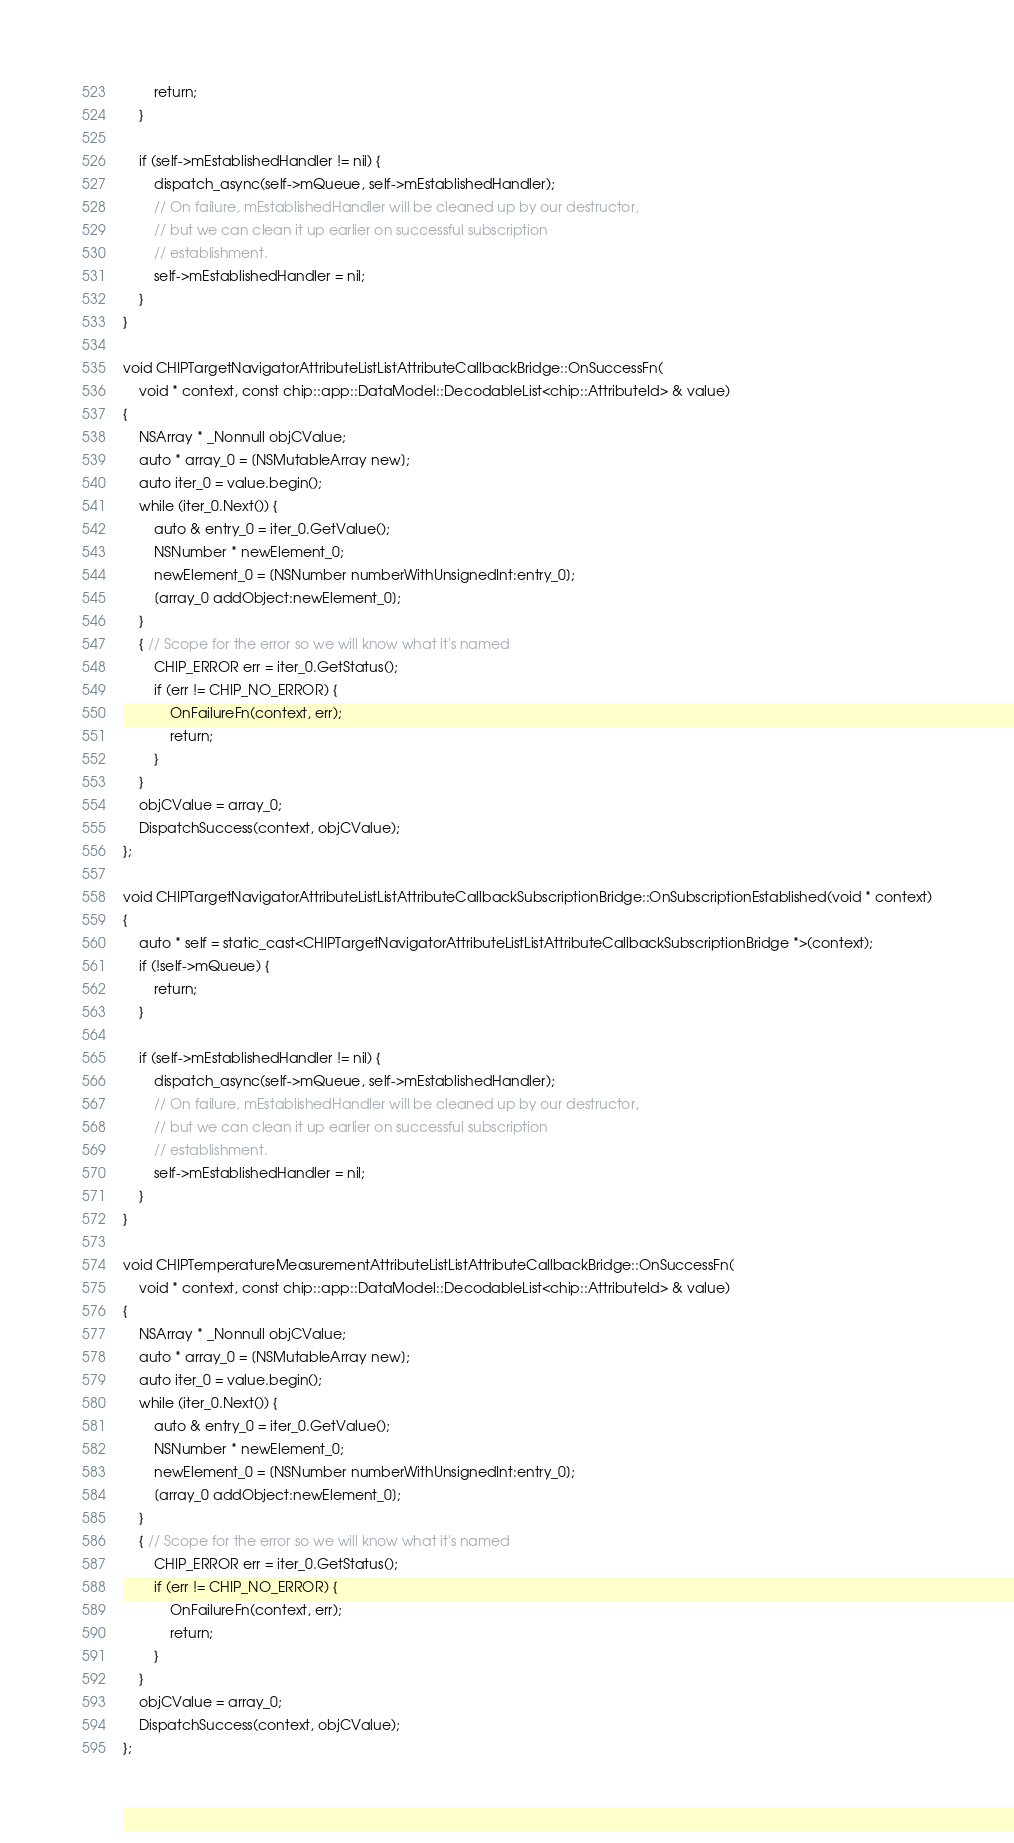Convert code to text. <code><loc_0><loc_0><loc_500><loc_500><_ObjectiveC_>        return;
    }

    if (self->mEstablishedHandler != nil) {
        dispatch_async(self->mQueue, self->mEstablishedHandler);
        // On failure, mEstablishedHandler will be cleaned up by our destructor,
        // but we can clean it up earlier on successful subscription
        // establishment.
        self->mEstablishedHandler = nil;
    }
}

void CHIPTargetNavigatorAttributeListListAttributeCallbackBridge::OnSuccessFn(
    void * context, const chip::app::DataModel::DecodableList<chip::AttributeId> & value)
{
    NSArray * _Nonnull objCValue;
    auto * array_0 = [NSMutableArray new];
    auto iter_0 = value.begin();
    while (iter_0.Next()) {
        auto & entry_0 = iter_0.GetValue();
        NSNumber * newElement_0;
        newElement_0 = [NSNumber numberWithUnsignedInt:entry_0];
        [array_0 addObject:newElement_0];
    }
    { // Scope for the error so we will know what it's named
        CHIP_ERROR err = iter_0.GetStatus();
        if (err != CHIP_NO_ERROR) {
            OnFailureFn(context, err);
            return;
        }
    }
    objCValue = array_0;
    DispatchSuccess(context, objCValue);
};

void CHIPTargetNavigatorAttributeListListAttributeCallbackSubscriptionBridge::OnSubscriptionEstablished(void * context)
{
    auto * self = static_cast<CHIPTargetNavigatorAttributeListListAttributeCallbackSubscriptionBridge *>(context);
    if (!self->mQueue) {
        return;
    }

    if (self->mEstablishedHandler != nil) {
        dispatch_async(self->mQueue, self->mEstablishedHandler);
        // On failure, mEstablishedHandler will be cleaned up by our destructor,
        // but we can clean it up earlier on successful subscription
        // establishment.
        self->mEstablishedHandler = nil;
    }
}

void CHIPTemperatureMeasurementAttributeListListAttributeCallbackBridge::OnSuccessFn(
    void * context, const chip::app::DataModel::DecodableList<chip::AttributeId> & value)
{
    NSArray * _Nonnull objCValue;
    auto * array_0 = [NSMutableArray new];
    auto iter_0 = value.begin();
    while (iter_0.Next()) {
        auto & entry_0 = iter_0.GetValue();
        NSNumber * newElement_0;
        newElement_0 = [NSNumber numberWithUnsignedInt:entry_0];
        [array_0 addObject:newElement_0];
    }
    { // Scope for the error so we will know what it's named
        CHIP_ERROR err = iter_0.GetStatus();
        if (err != CHIP_NO_ERROR) {
            OnFailureFn(context, err);
            return;
        }
    }
    objCValue = array_0;
    DispatchSuccess(context, objCValue);
};
</code> 